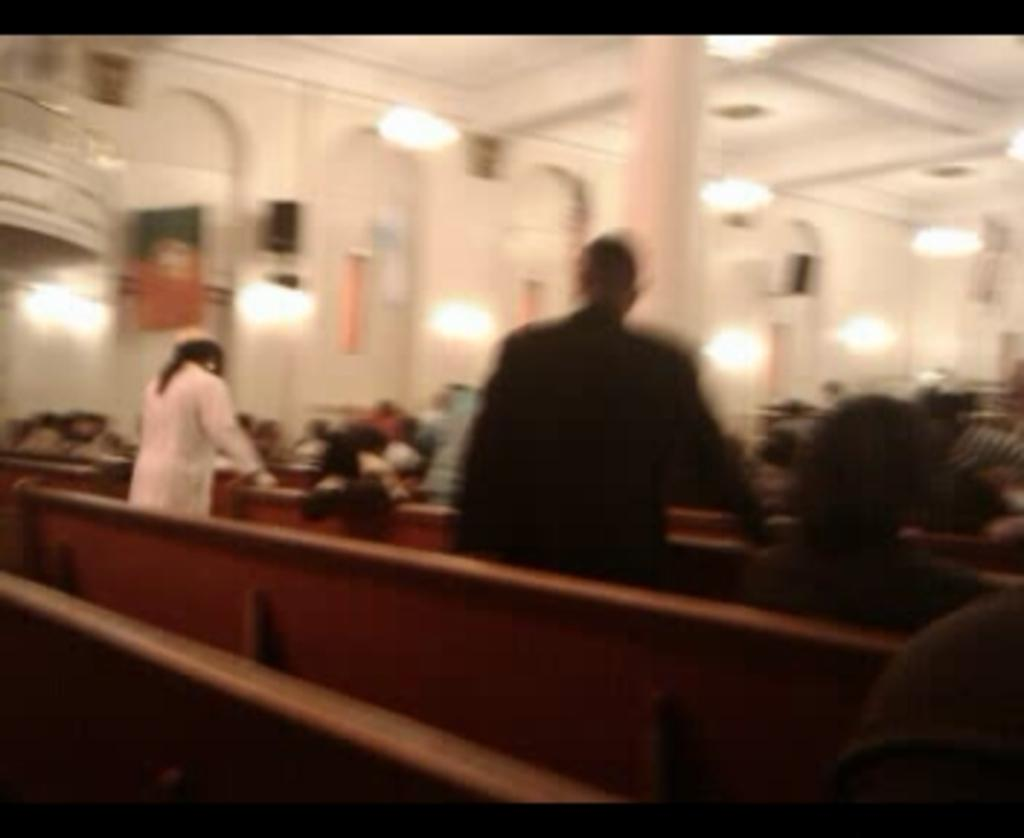What are the people in the image doing? There are people standing and sitting on benches in the image. What can be seen on the ceiling in the image? There are lights on the ceiling in the image. How would you describe the background of the image? The background of the image appears blurry. Can you see any chickens running across the train tracks in the image? There is no train or train tracks present in the image, and therefore no chickens can be seen running across them. 